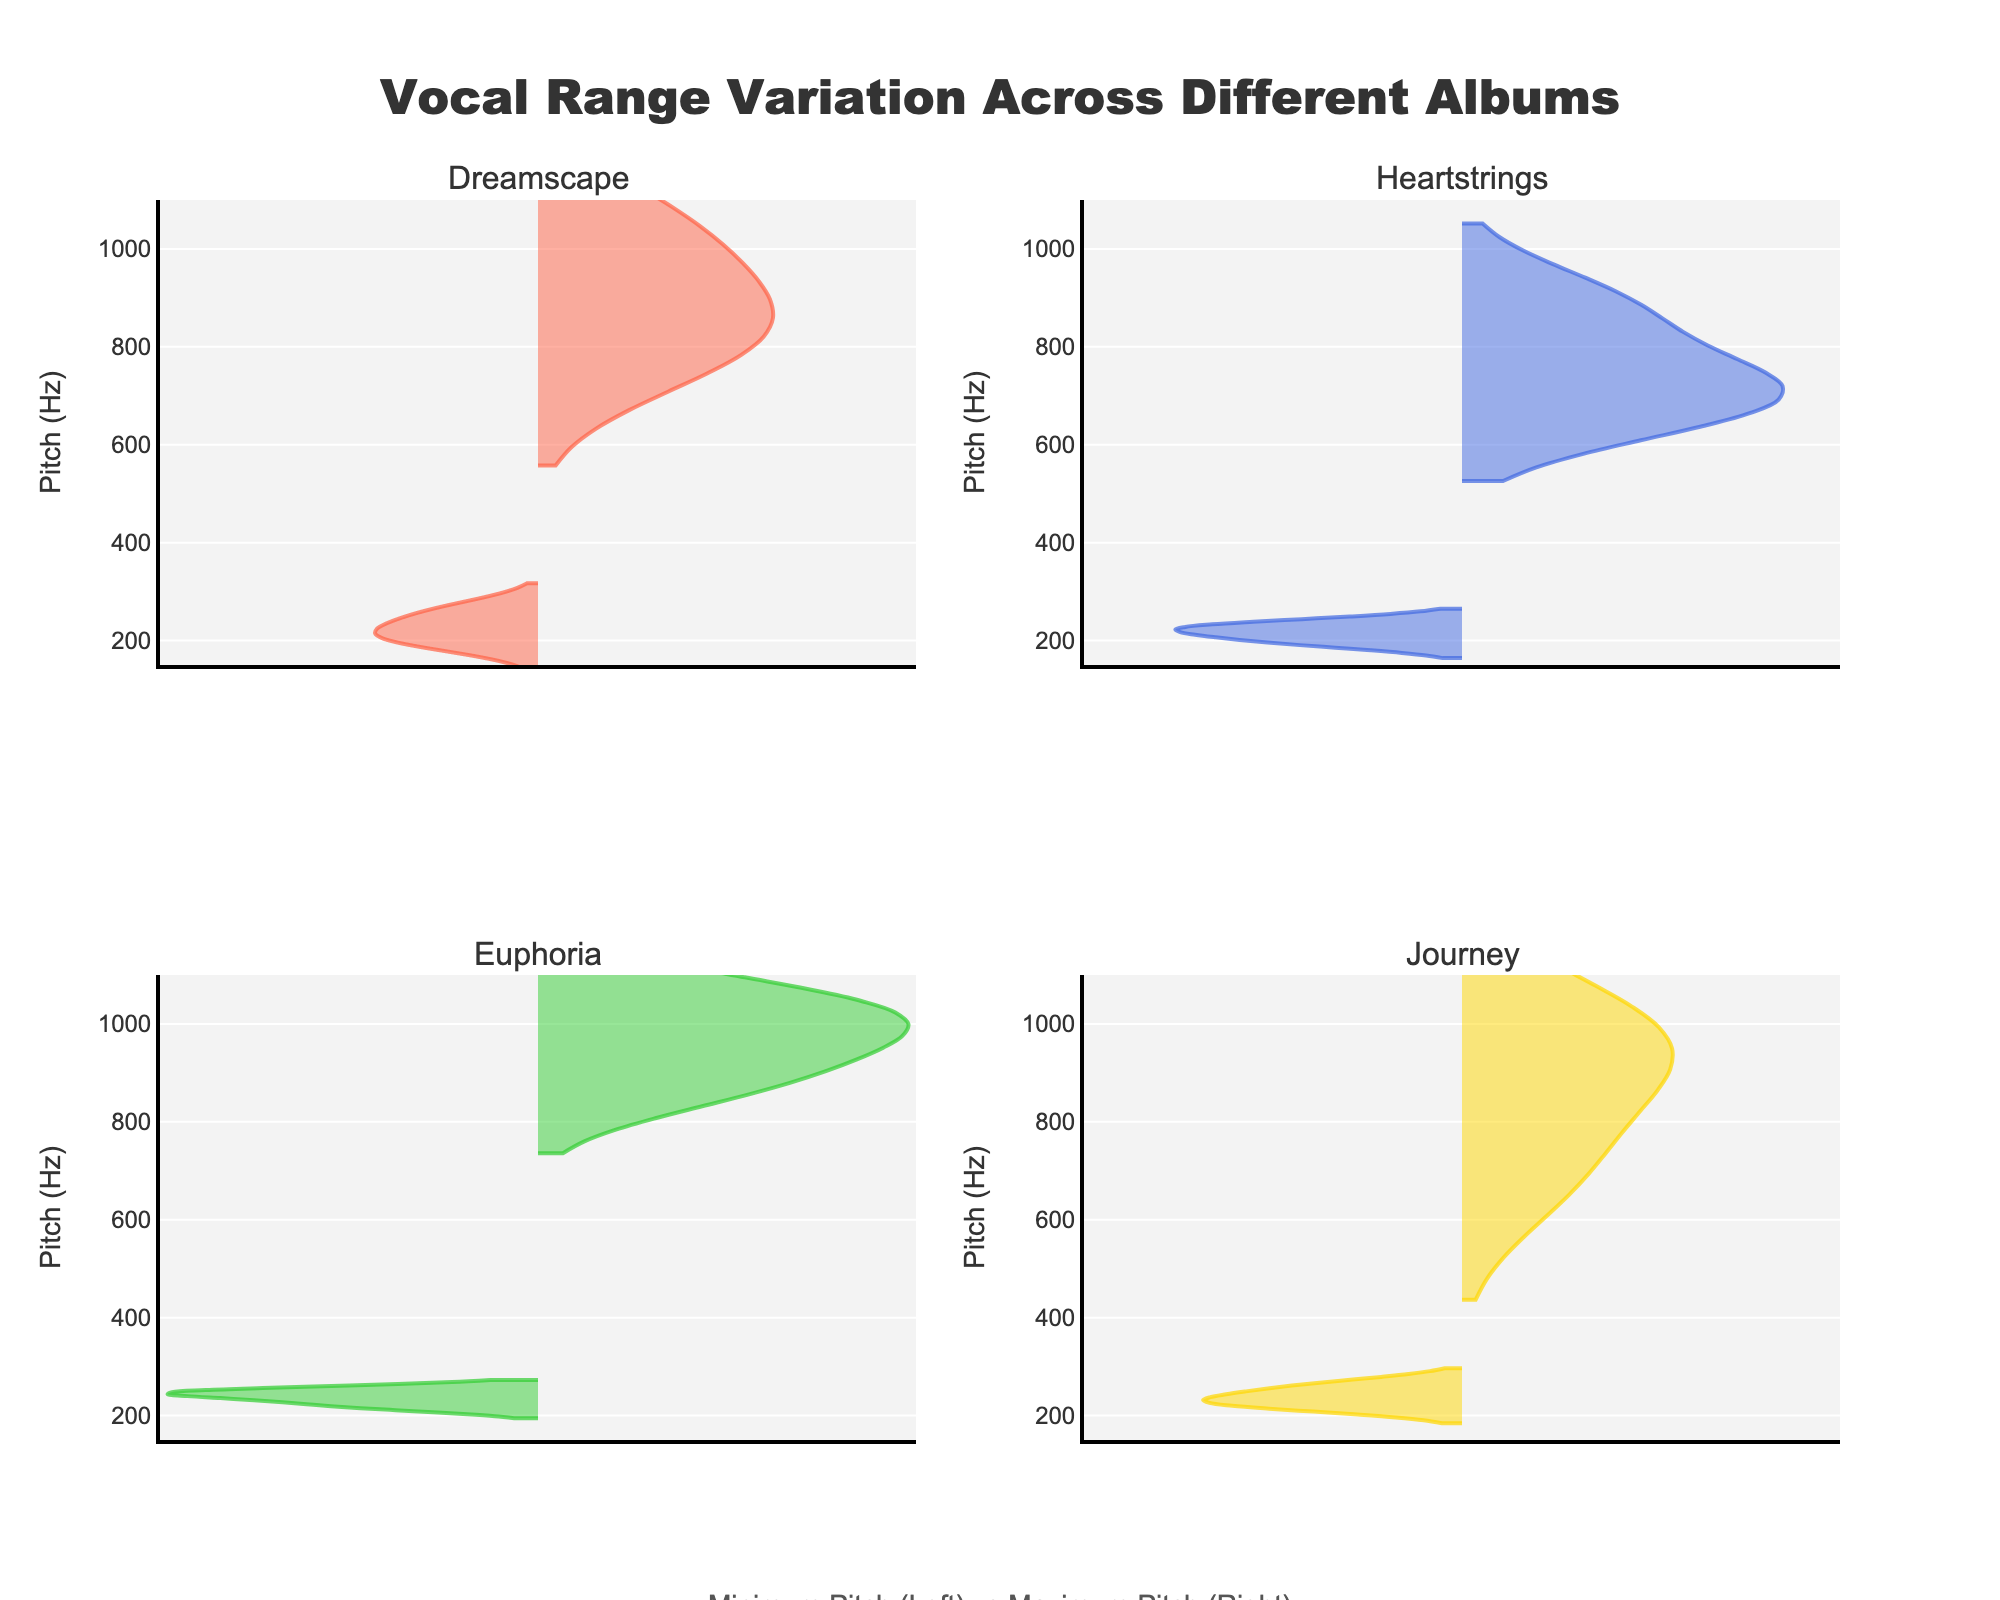What is the title of the figure? The title of the figure is typically displayed prominently and usually provides a concise summary of the figure's content. In this case, the title is clearly placed at the top.
Answer: Vocal Range Variation Across Different Albums Which album shows the widest range between the minimum and maximum pitch? To identify which album has the widest range between the minimum and maximum pitch, look for the album with the largest visual separation between the left and right violins in each subplot.
Answer: Dreamscape What is the range of the y-axis? The range of the y-axis can be found by observing the numerical limits on the left side of the vertical axis. The range has been set according to the configuration.
Answer: 150 to 1100 Hz How many albums are compared in the plot? The plot features four subplots, each representing a different album. The titles of the subplots give away the names of these albums.
Answer: 4 Which album has the lowest minimum pitch observation, and what is its value? To determine the lowest minimum pitch observation, inspect the lowest point on the violin plots on the left side of each subplot. The minimum pitch for each album can be read from these points.
Answer: Heartstrings, 196 Hz For which album are the maximum pitches above 1000 Hz observed? Review the violin plots for the maximum pitch (right side of each subplot) to see where the values exceed 1000 Hz. Specifically, track which album has one or more values reaching this threshold.
Answer: Dreamscape and Euphoria Compare the average minimum pitch between “Heartstrings” and “Journey”. The average minimum pitch can be inferred by observing the median line within the violin plots, which approximately indicates the center of the distribution. Compare the medians for "Heartstrings" and "Journey".
Answer: Journey has a slightly higher average minimum pitch than Heartstrings Which album has the narrowest vocal range overall? The narrowest vocal range can be established by looking at the album where the violin plots for minimum and maximum pitch are the closest together, signifying a smaller difference between the two.
Answer: Heartstrings Identify the album where the maximum pitch seems more widely varied. A more varied pitch range can be spotted by a wider and more spread-out violin plot on the right side within a given subplot. This indicates a larger variability in maximum pitch values.
Answer: Journey 